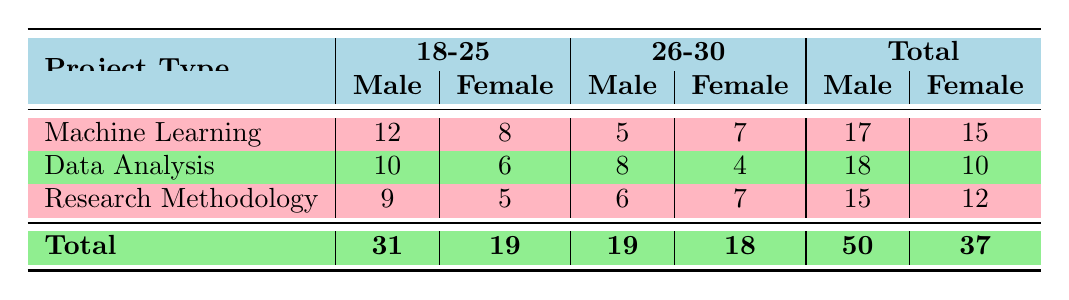What is the total number of students in the Data Analysis project? By looking at the Data Analysis row, we see that the total number of students in this project is given under the Total column, which is 28.
Answer: 28 How many male students are involved in Machine Learning projects? Referring to the Machine Learning row, we can see there are 12 male students aged 18-25 and 5 male students aged 26-30. Adding these gives us 12 + 5 = 17 male students.
Answer: 17 What is the total number of female students in Research Methodology? In the Research Methodology row, there are 5 female students aged 18-25 and 7 female students aged 26-30. Adding these gives us 5 + 7 = 12 female students.
Answer: 12 Are there more male students involved in Data Analysis or Research Methodology? The number of male students in Data Analysis is 10 (age 18-25) + 8 (age 26-30) = 18. For Research Methodology, it is 9 (age 18-25) + 6 (age 26-30) = 15. Since 18 > 15, there are more male students in Data Analysis.
Answer: Yes What is the average number of female students in the 18-25 age group across all project types? The total number of female students aged 18-25 is calculated from each project type: Machine Learning (8) + Data Analysis (6) + Research Methodology (5) = 19. There are three projects, so we average this as 19 / 3 = approximately 6.33.
Answer: 6.33 How many more male students are in the 18-25 age group compared to the 26-30 age group across all project types? We first find the total number of male students in the 18-25 age group: Machine Learning (12) + Data Analysis (10) + Research Methodology (9) = 31. Then, we find the 26-30 age group: Machine Learning (5) + Data Analysis (8) + Research Methodology (6) = 19. The difference is 31 - 19 = 12.
Answer: 12 What is the total number of students across all projects? To find the total number of students, we sum the Total column: Machine Learning (15) + Data Analysis (18) + Research Methodology (12) = 45.
Answer: 45 Are there fewer female students in the 26-30 age group compared to the 18-25 age group across all project types? For 26-30 age group, there are 7 (Machine Learning) + 4 (Data Analysis) + 7 (Research Methodology) = 18. For 18-25 age group, there are 8 + 6 + 5 = 19. Since 18 < 19, there are indeed fewer female students in the 26-30 age group.
Answer: Yes What is the total number of male students in all project types combined? The total number of male students can be calculated by adding male students from each project type: Machine Learning (17) + Data Analysis (18) + Research Methodology (15) = 50.
Answer: 50 What percentage of the total students are female? The total number of female students is 37. The total number of students is 50. The percentage of female students is calculated as (37/50) * 100 = 74%.
Answer: 74% 